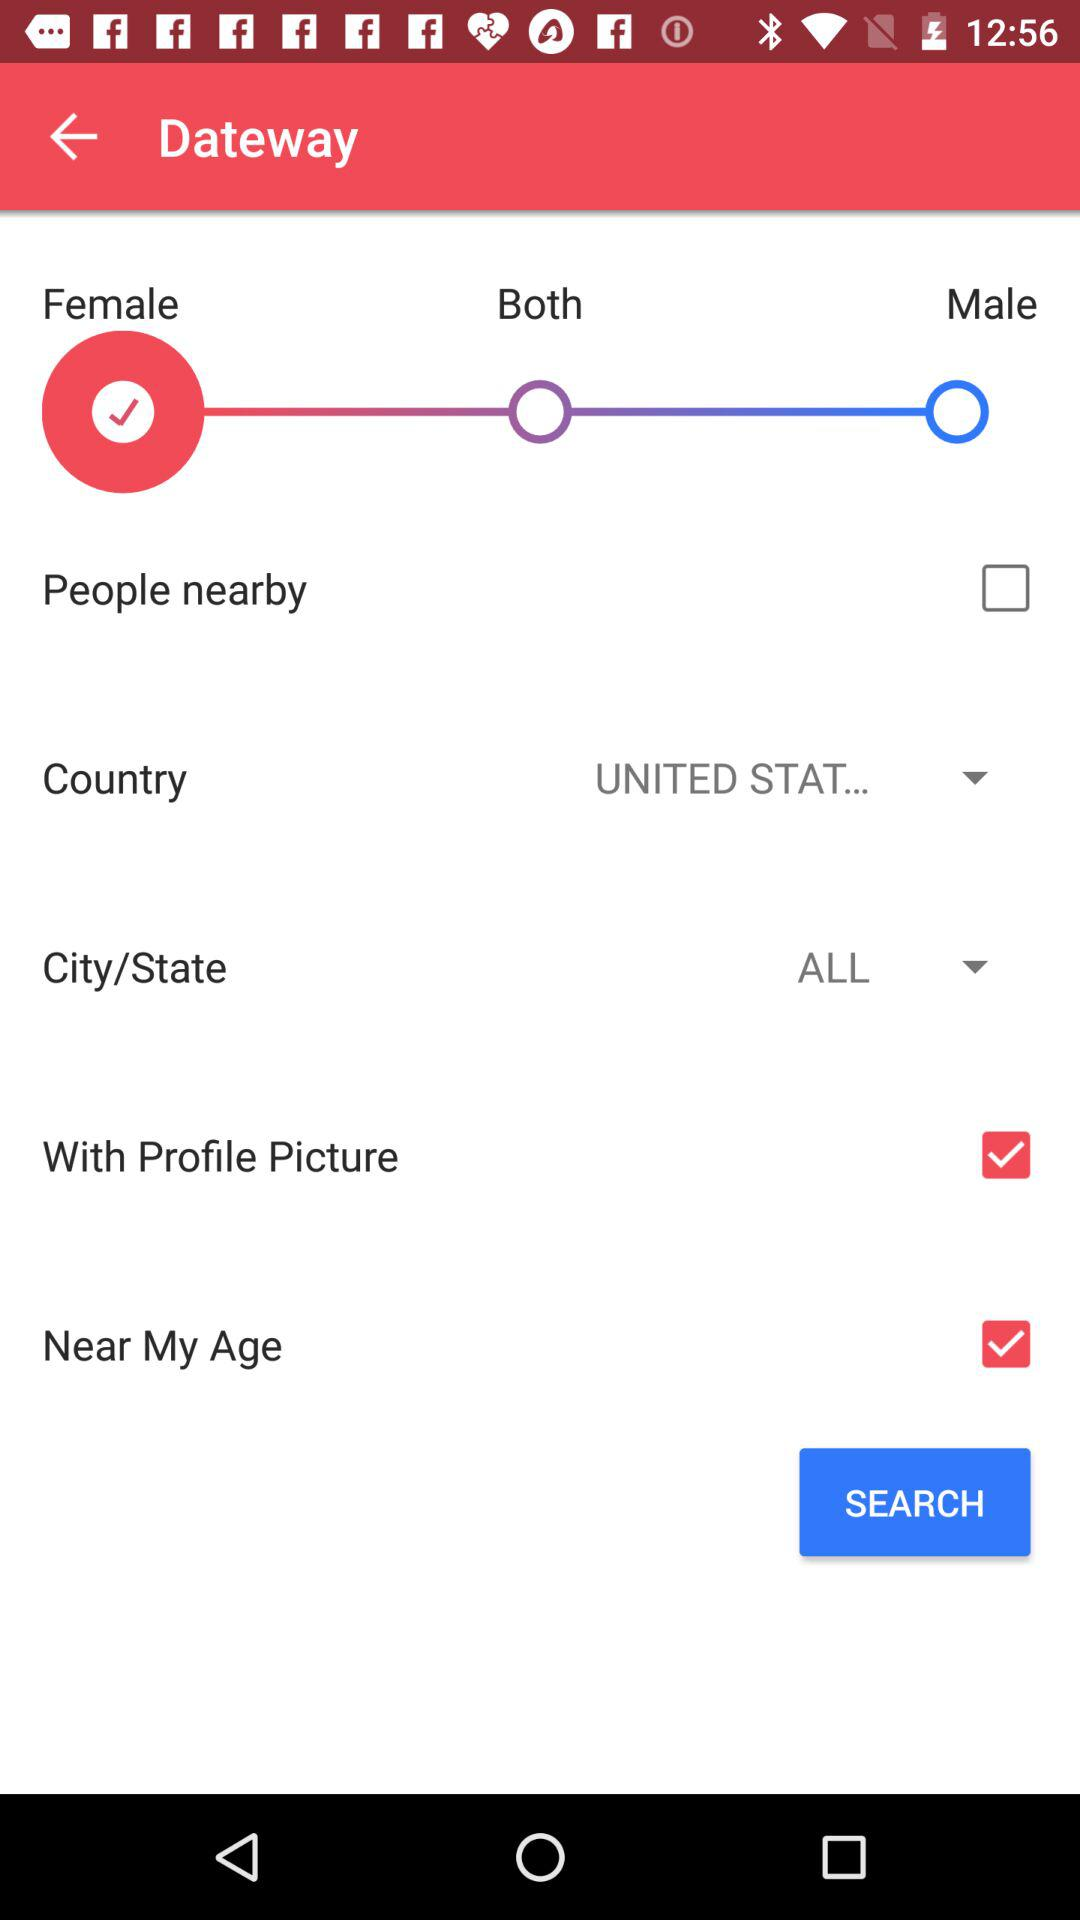What is the status of "People nearby"? The status is "off". 